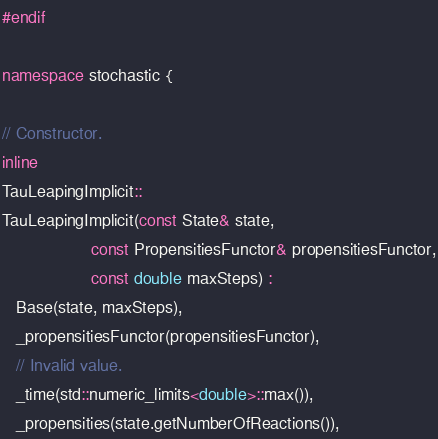Convert code to text. <code><loc_0><loc_0><loc_500><loc_500><_C++_>#endif

namespace stochastic {

// Constructor.
inline
TauLeapingImplicit::
TauLeapingImplicit(const State& state,
                   const PropensitiesFunctor& propensitiesFunctor,
                   const double maxSteps) :
   Base(state, maxSteps),
   _propensitiesFunctor(propensitiesFunctor),
   // Invalid value.
   _time(std::numeric_limits<double>::max()),
   _propensities(state.getNumberOfReactions()),</code> 